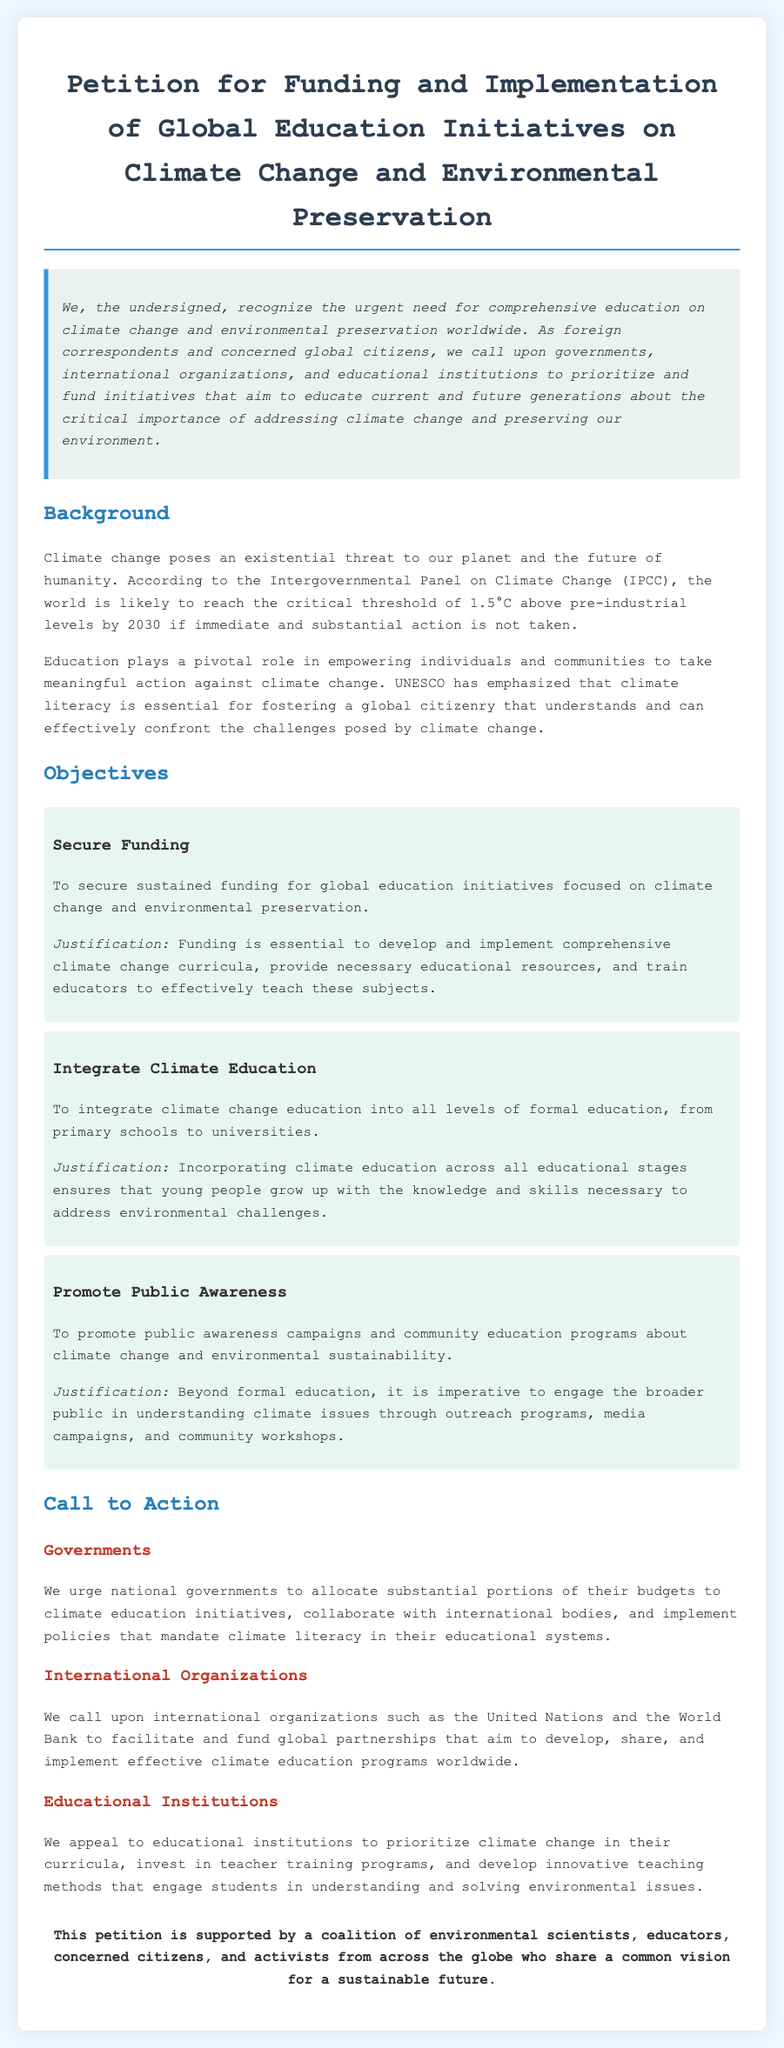What is the title of the petition? The title of the petition is clearly stated at the top of the document.
Answer: Petition for Funding and Implementation of Global Education Initiatives on Climate Change and Environmental Preservation What is the main threat posed by climate change according to the document? The document outlines the existential threat caused by climate change, as highlighted in the background section.
Answer: Existential threat What organization emphasized the importance of climate literacy? The document references a significant organization that stresses the need for climate literacy in education.
Answer: UNESCO What is one of the key objectives related to funding? This objective focuses on a specific aspect of funding for education initiatives.
Answer: Secure Funding Who is urged to allocate substantial portions of their budgets to climate education initiatives? The document specifies which entities are called upon for budget allocations.
Answer: National governments What are public awareness campaigns intended to promote? This is outlined in the objectives and refers to the aim of engaging the broader public.
Answer: Climate change and environmental sustainability Which level of education is the document advocating to integrate climate education into? The document mentions specific educational levels for integration of climate education.
Answer: All levels of formal education What section follows the objectives in the document? This section directly addresses action steps required to implement the outlined goals.
Answer: Call to Action Which international organizations are called upon to facilitate partnerships for climate education? The document identifies specific international organizations for this purpose.
Answer: United Nations and World Bank How is the documentation structured visually? The structure of the document can be described based on its design elements.
Answer: Container, headings, sections, and bullet points 